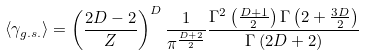Convert formula to latex. <formula><loc_0><loc_0><loc_500><loc_500>\left \langle \gamma _ { g . s . } \right \rangle = \left ( \frac { 2 D - 2 } { Z } \right ) ^ { D } \frac { 1 } { \pi ^ { \frac { D + 2 } { 2 } } } \frac { \Gamma ^ { 2 } \left ( \frac { D + 1 } { 2 } \right ) \Gamma \left ( 2 + \frac { 3 D } { 2 } \right ) } { \Gamma \left ( 2 D + 2 \right ) }</formula> 